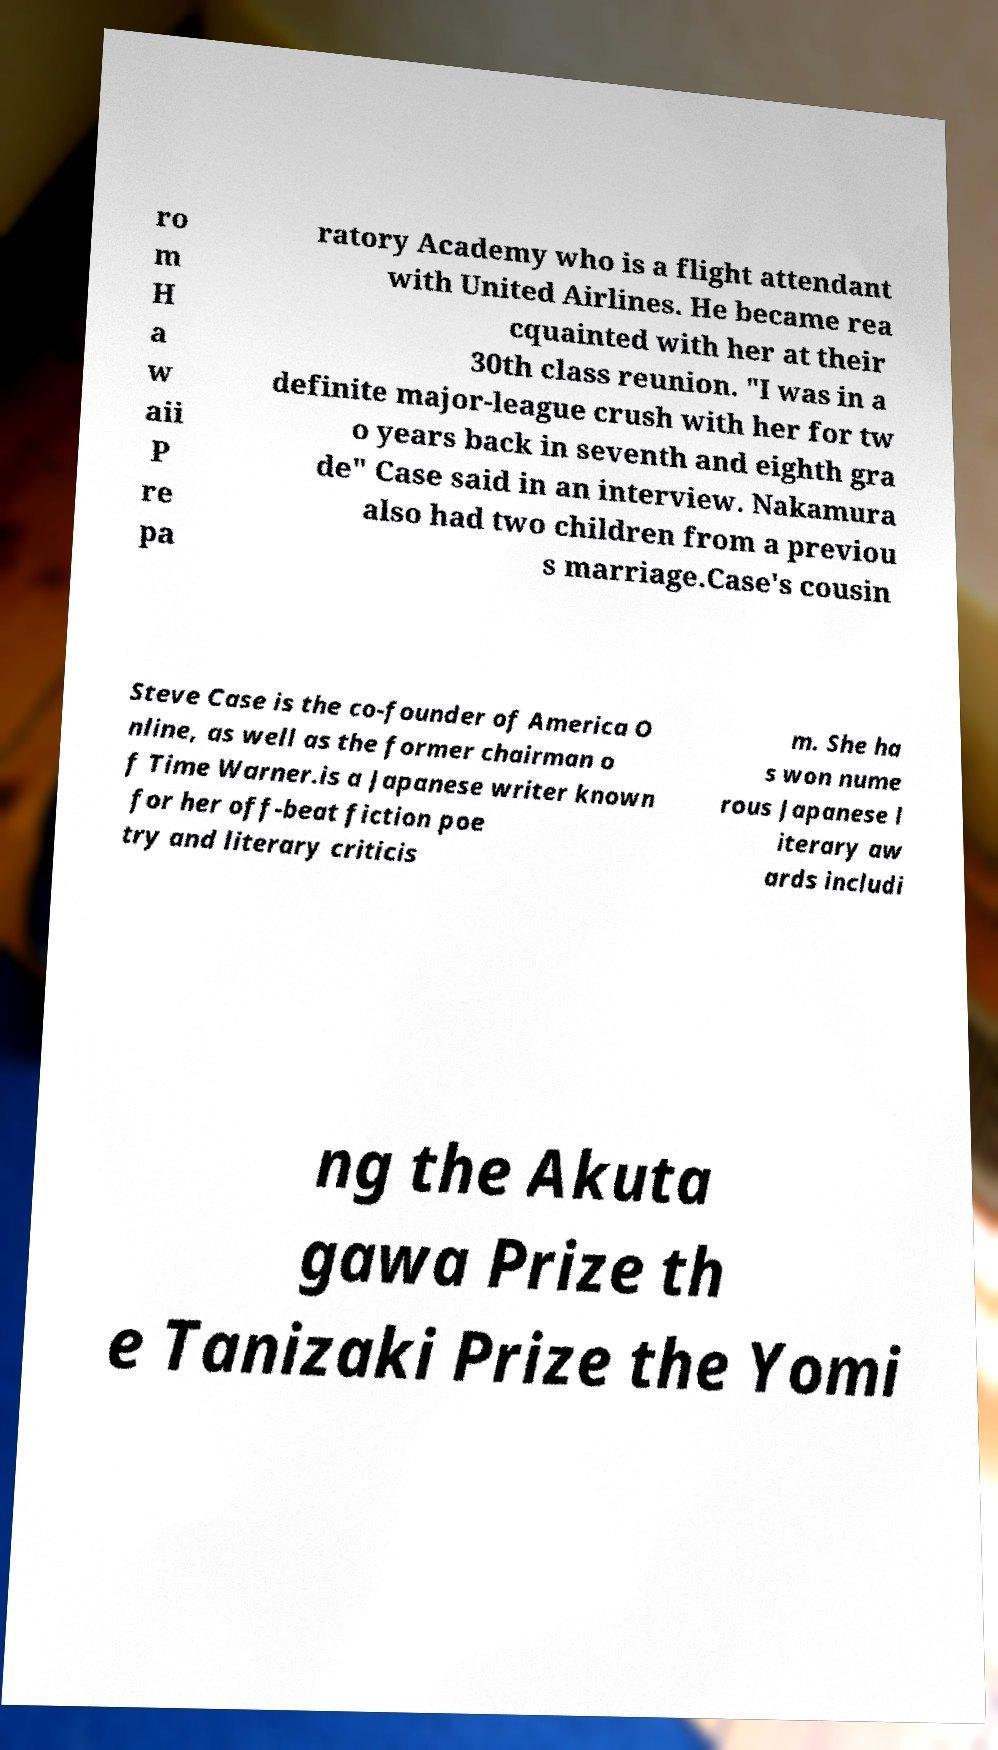For documentation purposes, I need the text within this image transcribed. Could you provide that? ro m H a w aii P re pa ratory Academy who is a flight attendant with United Airlines. He became rea cquainted with her at their 30th class reunion. "I was in a definite major-league crush with her for tw o years back in seventh and eighth gra de" Case said in an interview. Nakamura also had two children from a previou s marriage.Case's cousin Steve Case is the co-founder of America O nline, as well as the former chairman o f Time Warner.is a Japanese writer known for her off-beat fiction poe try and literary criticis m. She ha s won nume rous Japanese l iterary aw ards includi ng the Akuta gawa Prize th e Tanizaki Prize the Yomi 